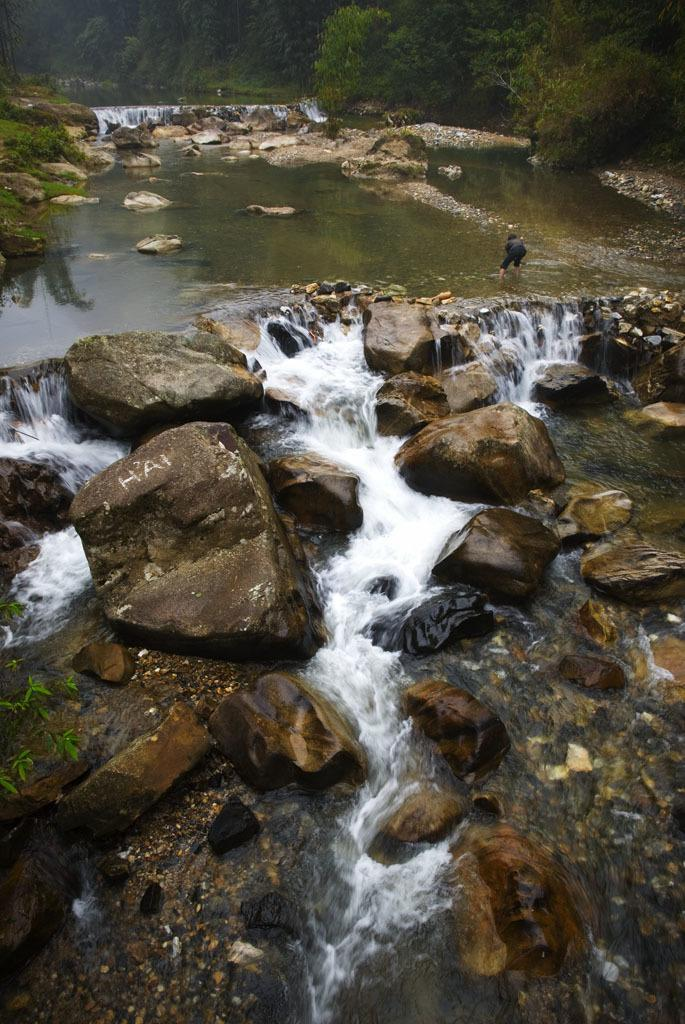What type of natural formation can be seen in the image? There are rocks in the image. What water feature is present in the image? There is a waterfall in the image. Can you describe the person in the image? There is a person standing in the water. What can be seen in the background of the image? Trees are present in the background of the image. How many cats are playing baseball with your dad in the image? There are no cats or your dad present in the image. The image features rocks, a waterfall, a person standing in the water, and trees in the background. 